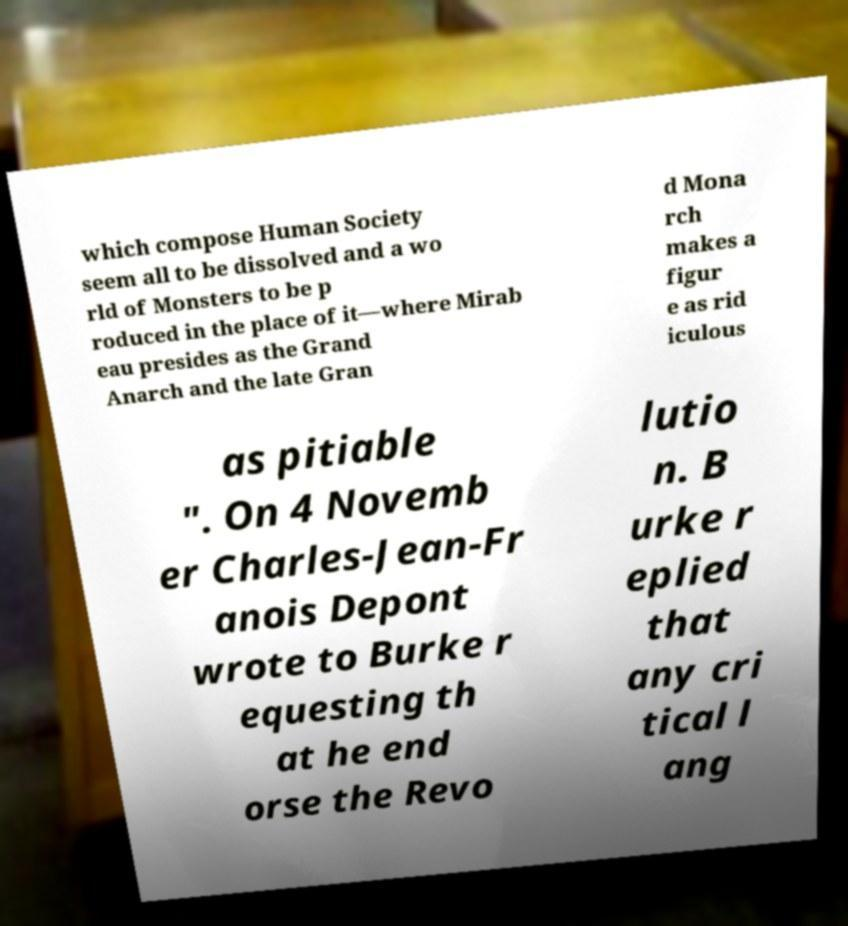Please read and relay the text visible in this image. What does it say? which compose Human Society seem all to be dissolved and a wo rld of Monsters to be p roduced in the place of it—where Mirab eau presides as the Grand Anarch and the late Gran d Mona rch makes a figur e as rid iculous as pitiable ". On 4 Novemb er Charles-Jean-Fr anois Depont wrote to Burke r equesting th at he end orse the Revo lutio n. B urke r eplied that any cri tical l ang 